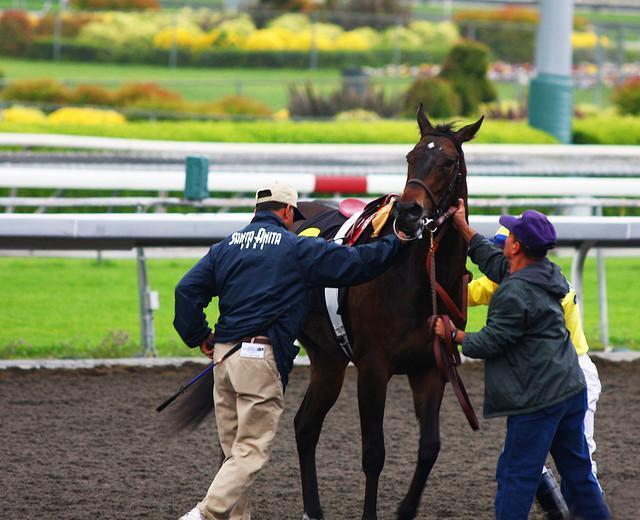How many men are in this photo?
Give a very brief answer. 2. How many people are visible?
Give a very brief answer. 3. 